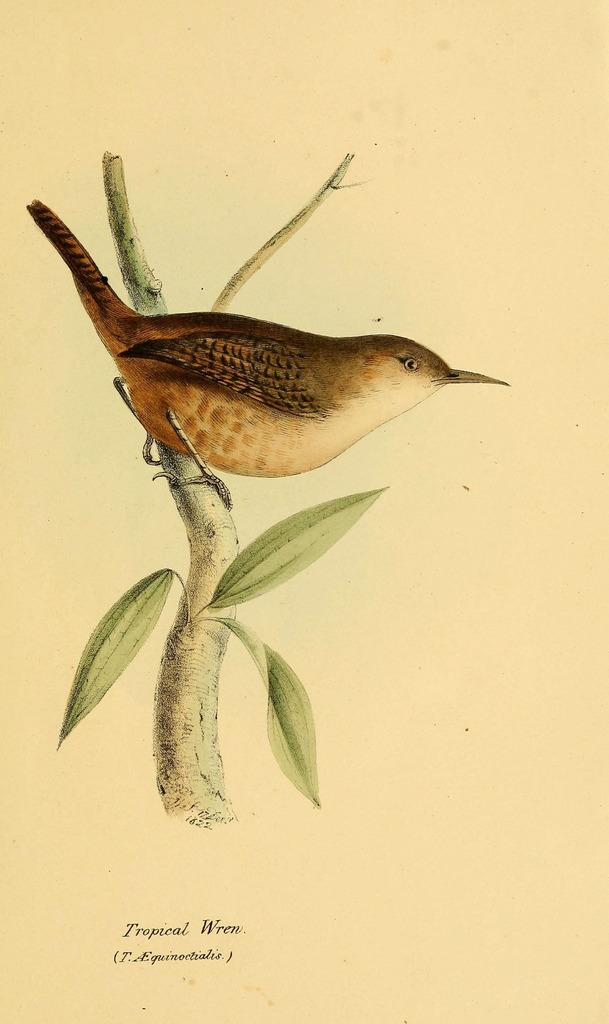What is depicted in the image? There is a picture of a bird in the image. Where is the bird located in the image? The bird is sitting on a branch of a tree. What else can be seen on the tree in the image? Leaves are present on the tree. Can you tell me what type of skin the stranger has in the image? There is no stranger present in the image, and therefore no skin to describe. 